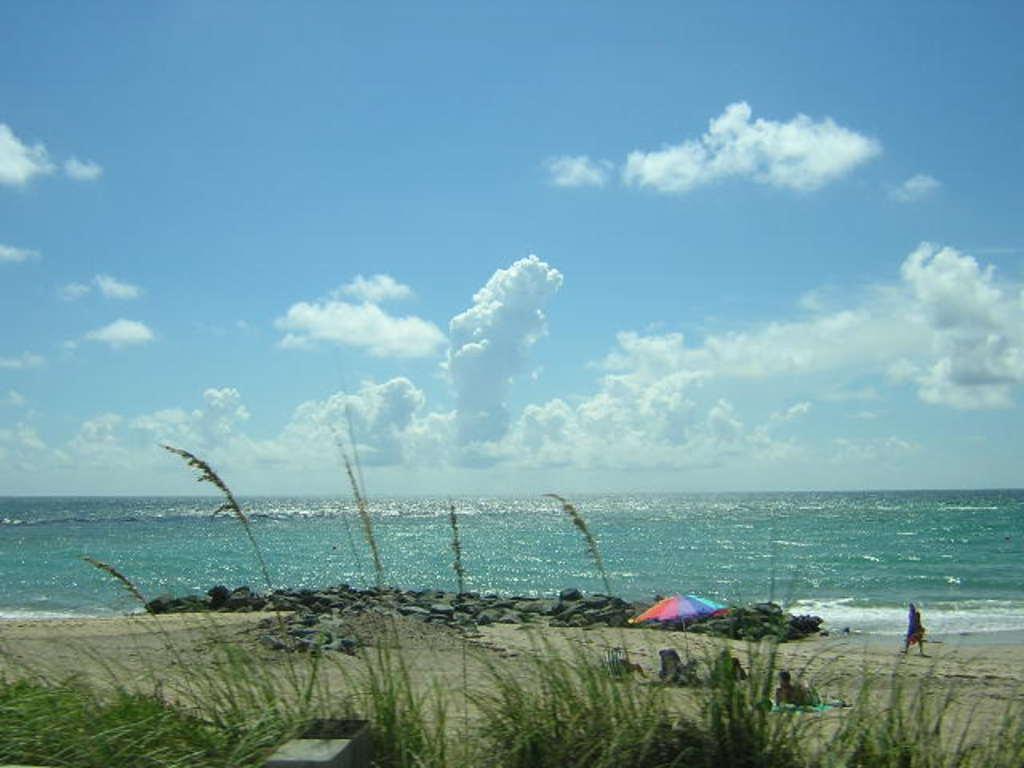Could you give a brief overview of what you see in this image? The picture is clicked near a shore. In the foreground of the picture there are plants, soil, stones, people. In the center of the picture there is a water body. Sky is sunny. 